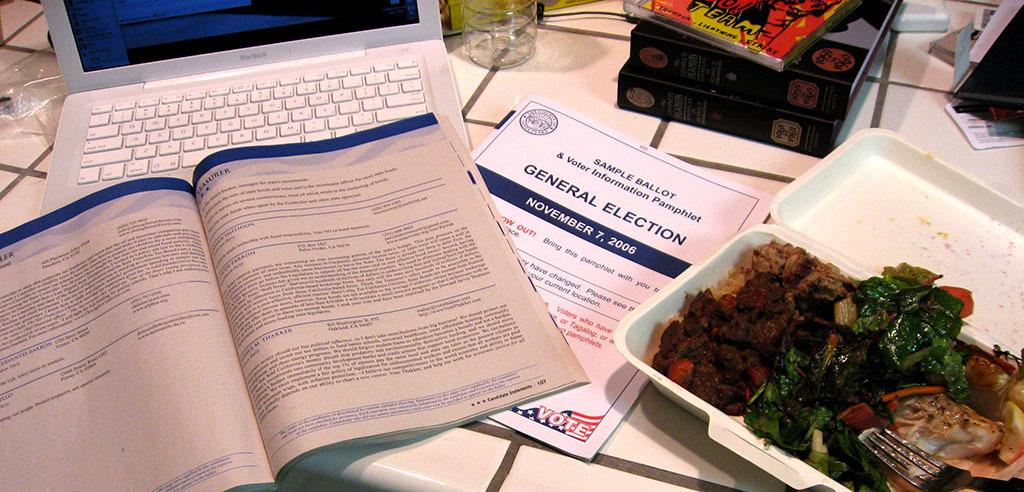<image>
Create a compact narrative representing the image presented. A booklet that says General Election on it sits on a table beside a laptop and other pamphlets. 